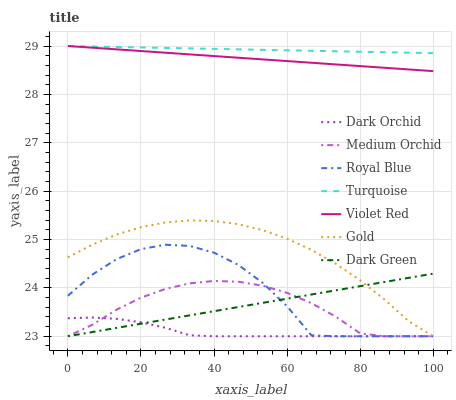Does Gold have the minimum area under the curve?
Answer yes or no. No. Does Gold have the maximum area under the curve?
Answer yes or no. No. Is Gold the smoothest?
Answer yes or no. No. Is Gold the roughest?
Answer yes or no. No. Does Violet Red have the lowest value?
Answer yes or no. No. Does Gold have the highest value?
Answer yes or no. No. Is Dark Green less than Turquoise?
Answer yes or no. Yes. Is Violet Red greater than Dark Green?
Answer yes or no. Yes. Does Dark Green intersect Turquoise?
Answer yes or no. No. 